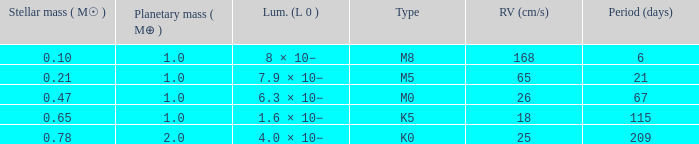What is the total stellar mass of the type m0? 0.47. 